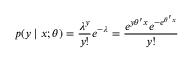<formula> <loc_0><loc_0><loc_500><loc_500>p ( y | x ; \theta ) = { \frac { \lambda ^ { y } } { y ! } } e ^ { - \lambda } = { \frac { e ^ { y \theta ^ { \prime } x } e ^ { - e ^ { \theta ^ { \prime } x } } } { y ! } }</formula> 